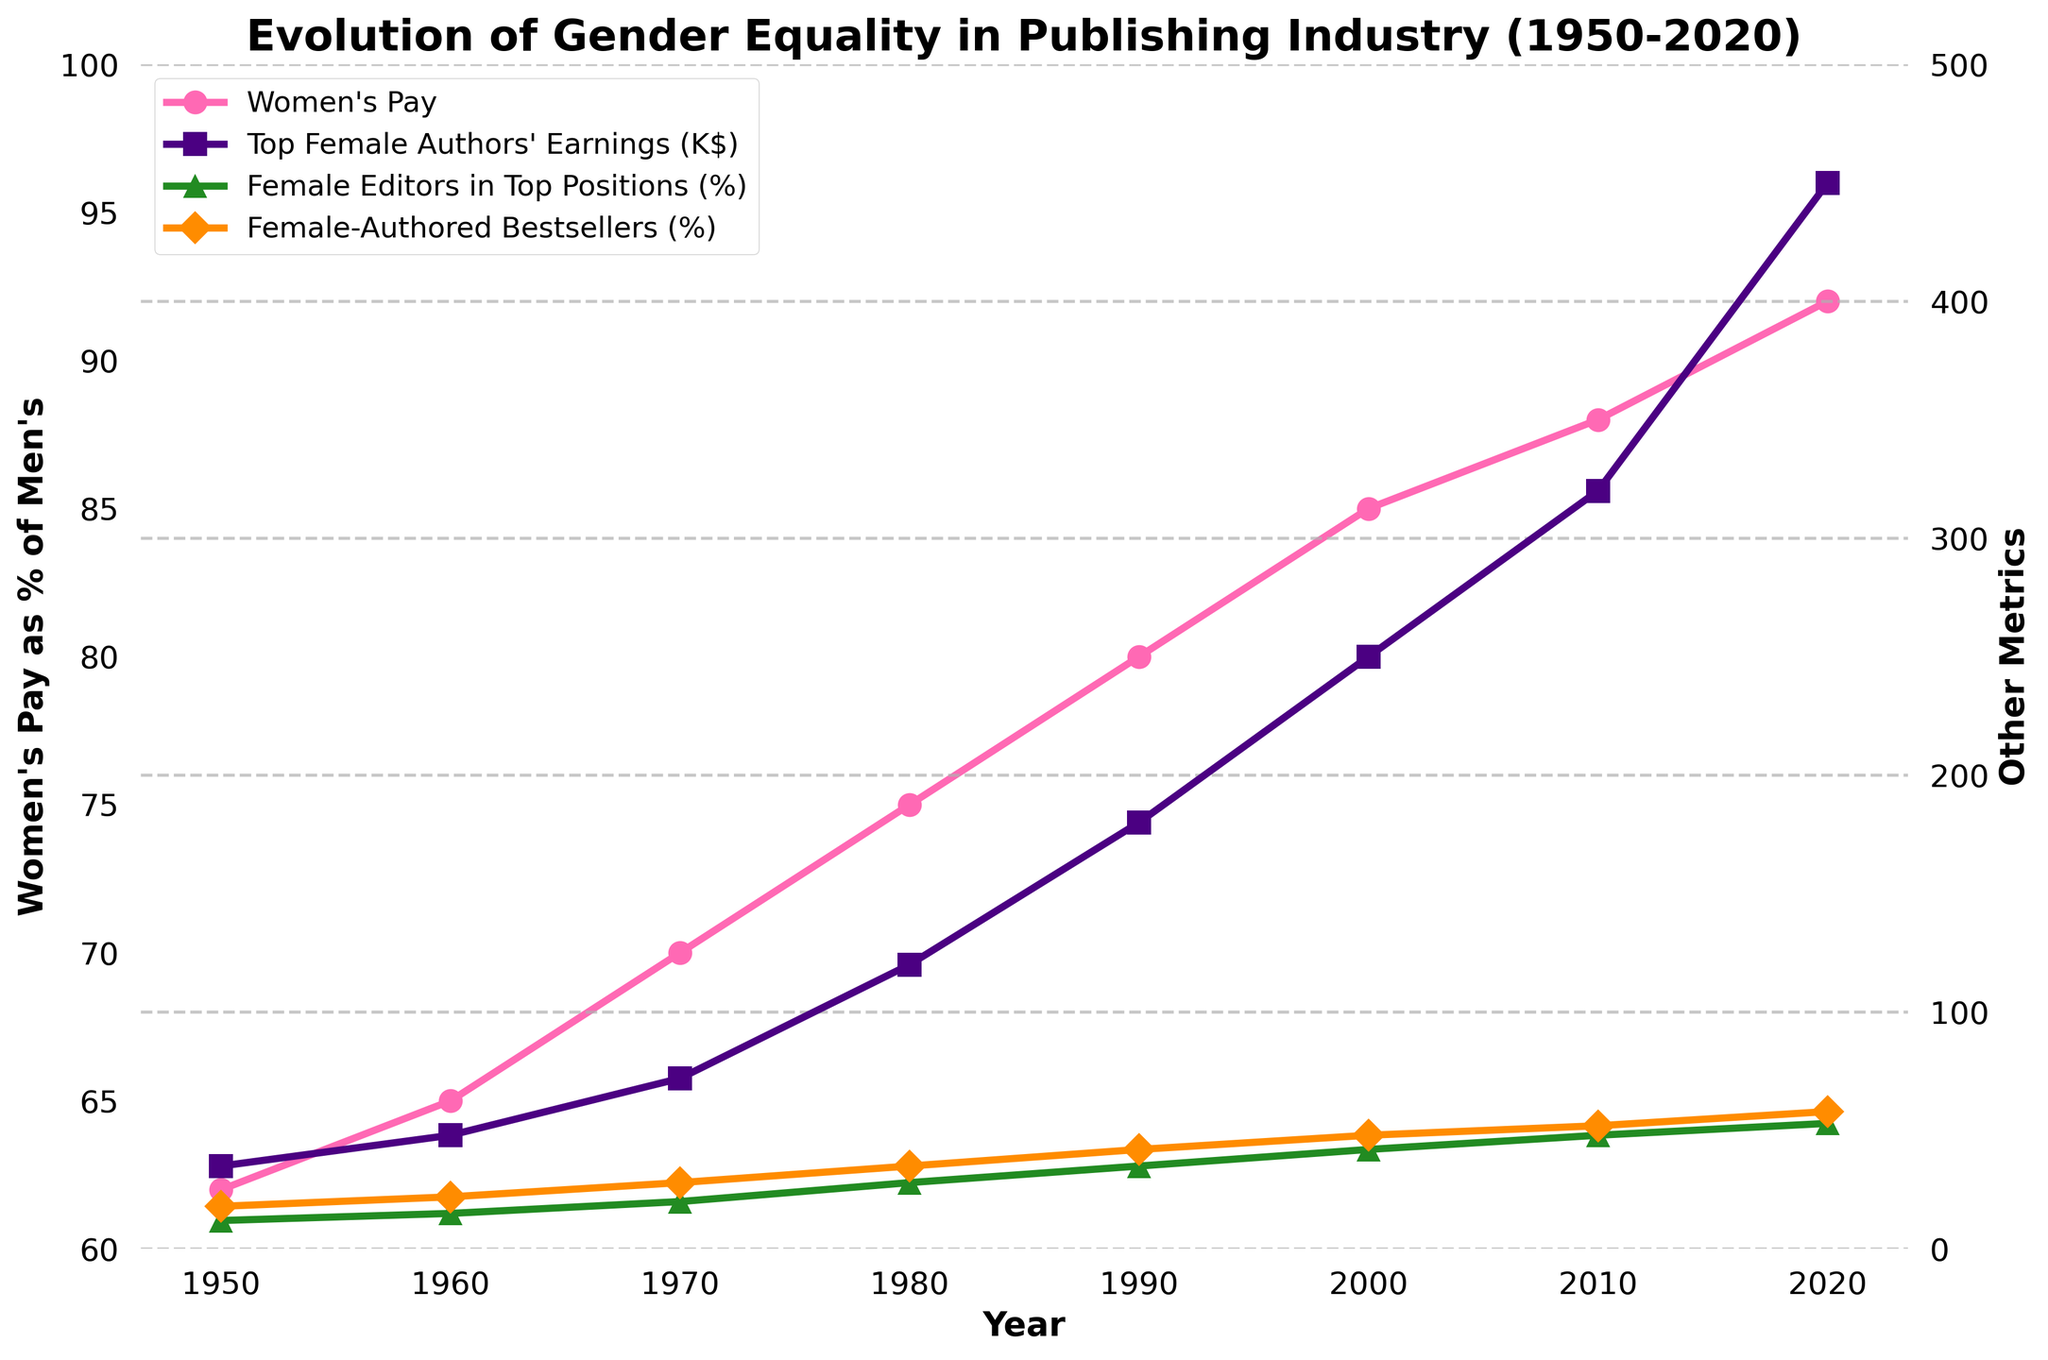What is the highest percentage of women's pay as compared to men's pay on the graph? Looking at the pink line representing "Women's Pay as % of Men's" on the graph, the highest point is reached in 2020. This point is at 92%.
Answer: 92% Compare the trend of "Female Editors in Top Positions (%)" and "Female-Authored Bestsellers (%)" from 1950 to 2020. Which one has a steeper increase? Observing the green and orange lines representing "Female Editors in Top Positions (%)" and "Female-Authored Bestsellers (%)" respectively, both lines show an increasing trend. However, by comparing the overall slopes, "Female Editors in Top Positions (%)" has a steeper increase from 12% in 1950 to 53% in 2020, while "Female-Authored Bestsellers (%)" increases from 18% to 58%.
Answer: Female Editors in Top Positions What was the pay of top female authors in 1980 and how does it compare to their pay in 2020? The purple line with square markers shows "Top Female Authors' Earnings." In 1980, the value is at 120,000 dollars. In 2020, it is at 450,000 dollars. To compare, 450,000 - 120,000 = 330,000 dollars increase.
Answer: 450,000 dollars; increased by 330,000 dollars What is the rate of increase in "Women's Pay as % of Men's" from 1950 to 2020? The pink line indicates this data point. In 1950, the pay is 62% and in 2020 it's 92%. The increase is 92 - 62 = 30 percentage points over 70 years, so the rate is 30 / 70 = about 0.43 percentage points per year.
Answer: 0.43 percentage points per year Identify the year where "Top Female Authors' Earnings" and "Female-Authored Bestsellers (%)" both first exceed their midpoints on the graph. The midpoint for "Top Female Authors' Earnings" (Y-axis range 0-500K) is 250,000 dollars, and for "Female-Authored Bestsellers (%)" (Y-axis range 0-100%) is 50%. Both cross their midpoints around 2010.
Answer: 2010 How did "Female Editors in Top Positions (%)" change from 1990 to 2010? The green line with triangle markers starts at 35% in 1990 and rises to 48% by 2010. The change is 48 - 35 = 13 percentage points.
Answer: Increased by 13 percentage points Between which years did "Women's Pay as % of Men's" see the largest increase? The pink line has increments between consecutive points. The largest increase is between 1970 (70%) and 1980 (75%), which is 75 - 70 = 5 percentage points.
Answer: Between 1970 and 1980 What is the approximate average earnings of top female authors over all the years shown? The purple line shows the "Top Female Authors' Earnings" in 1000s. Sum the values: 35 + 48 + 72 + 120 + 180 + 250 + 320 + 450 = 1475 (in 1000s). The average is 1475 / 8 = 184.375K dollars.
Answer: 184.375K dollars 